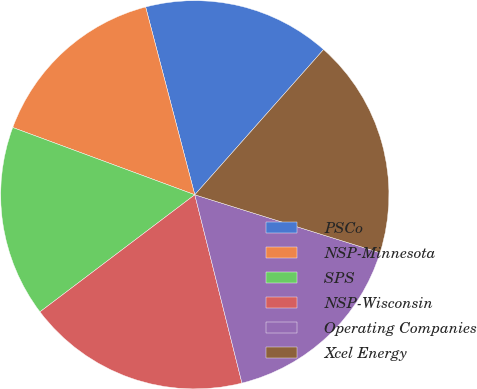<chart> <loc_0><loc_0><loc_500><loc_500><pie_chart><fcel>PSCo<fcel>NSP-Minnesota<fcel>SPS<fcel>NSP-Wisconsin<fcel>Operating Companies<fcel>Xcel Energy<nl><fcel>15.62%<fcel>15.29%<fcel>15.94%<fcel>18.6%<fcel>16.27%<fcel>18.28%<nl></chart> 